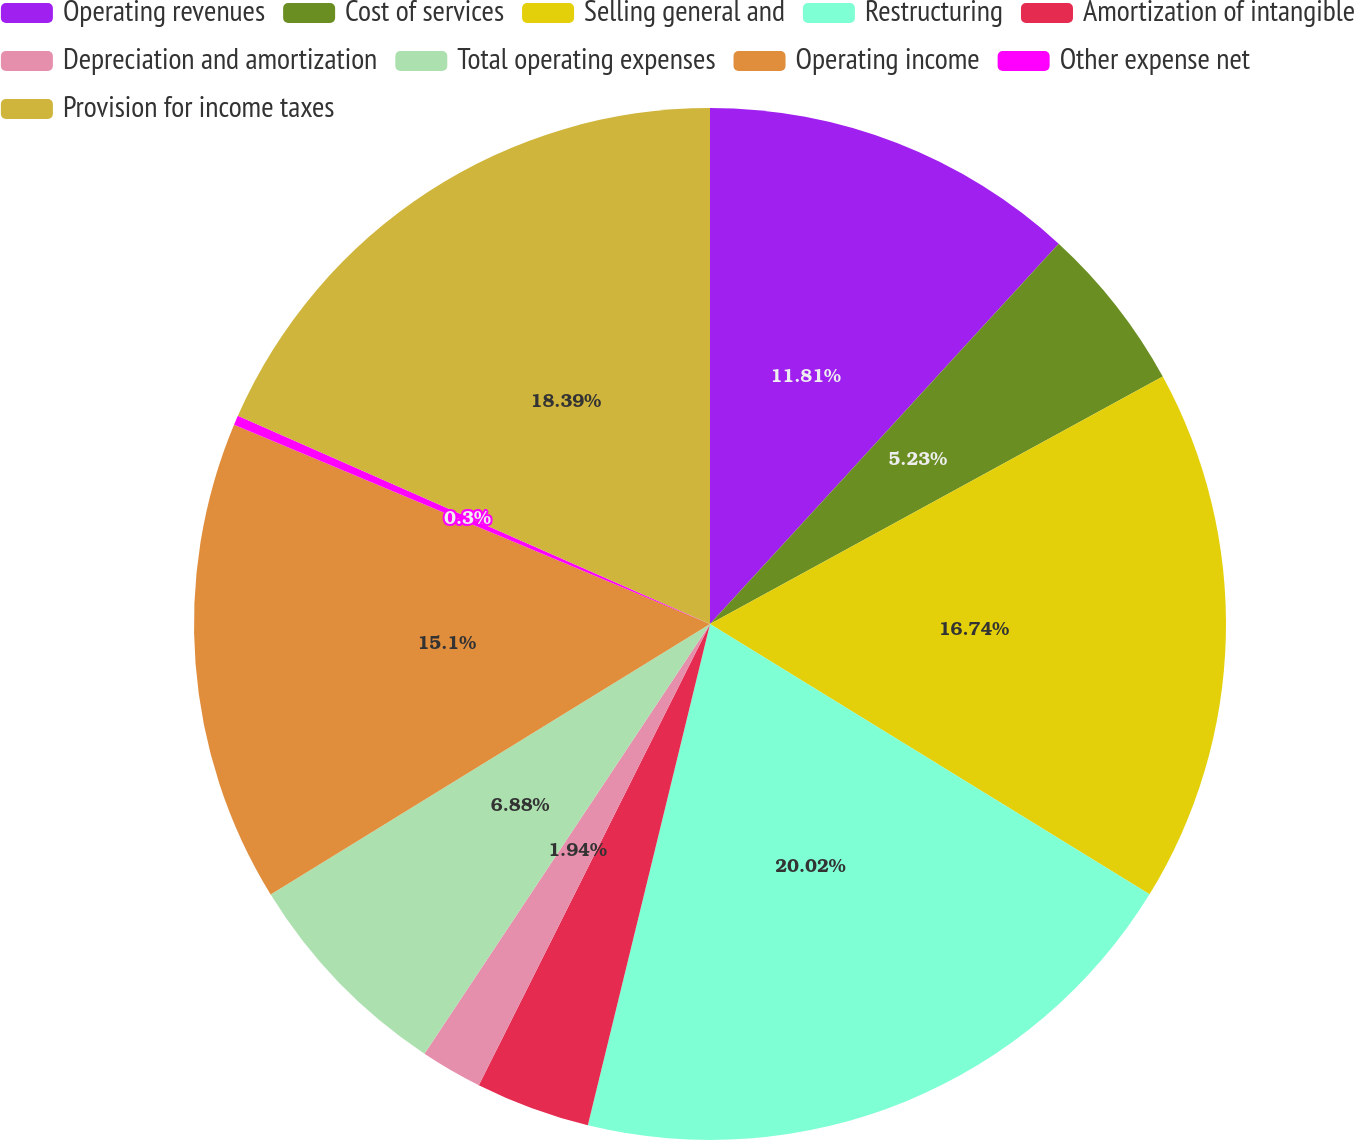Convert chart to OTSL. <chart><loc_0><loc_0><loc_500><loc_500><pie_chart><fcel>Operating revenues<fcel>Cost of services<fcel>Selling general and<fcel>Restructuring<fcel>Amortization of intangible<fcel>Depreciation and amortization<fcel>Total operating expenses<fcel>Operating income<fcel>Other expense net<fcel>Provision for income taxes<nl><fcel>11.81%<fcel>5.23%<fcel>16.74%<fcel>20.03%<fcel>3.59%<fcel>1.94%<fcel>6.88%<fcel>15.1%<fcel>0.3%<fcel>18.39%<nl></chart> 